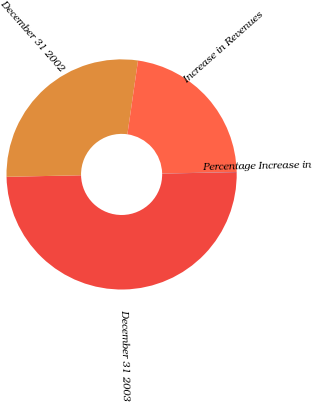<chart> <loc_0><loc_0><loc_500><loc_500><pie_chart><fcel>December 31 2003<fcel>December 31 2002<fcel>Increase in Revenues<fcel>Percentage Increase in<nl><fcel>49.99%<fcel>27.61%<fcel>22.38%<fcel>0.02%<nl></chart> 